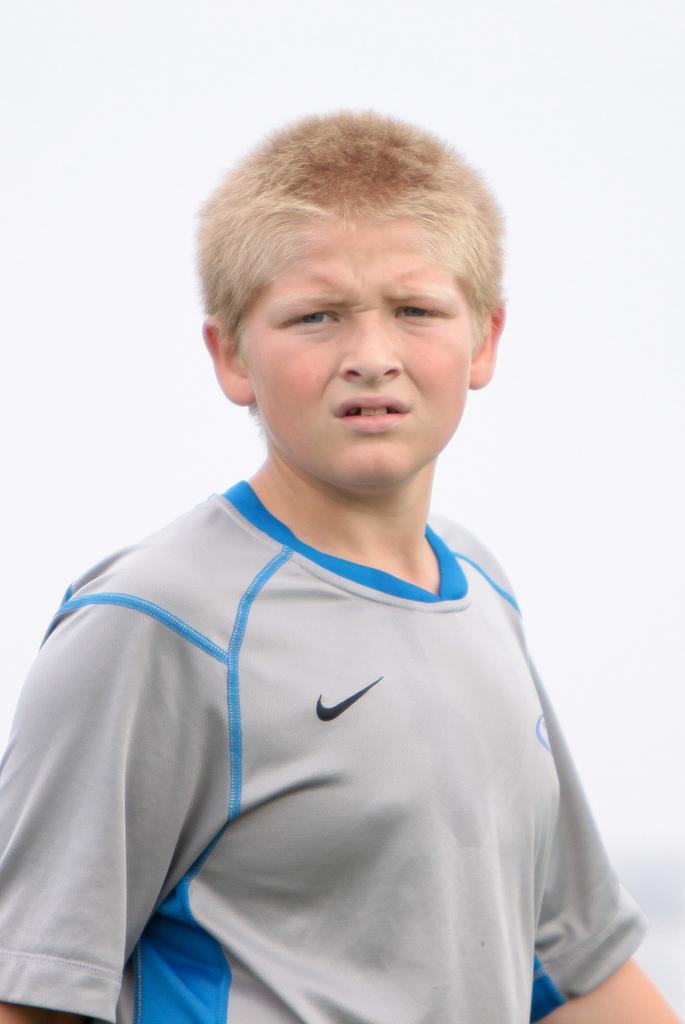What is the main subject of the image? There is a boy in the middle of the image. What is the boy wearing in the image? The boy is wearing a T-shirt in the image. Can you describe the T-shirt further? There is a logo on the T-shirt. How many legs does the sock have in the image? There is no sock present in the image. 